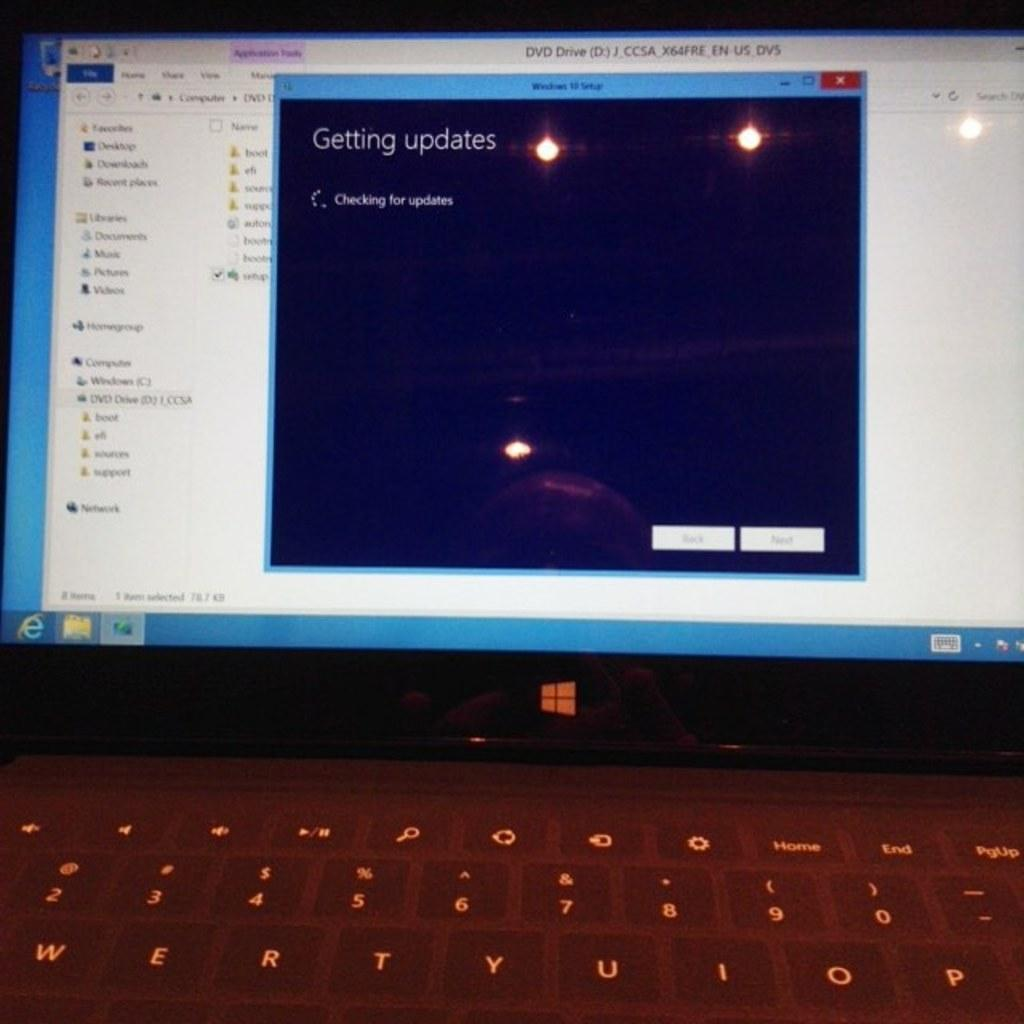Provide a one-sentence caption for the provided image. The computer is currently checking to find updates. 